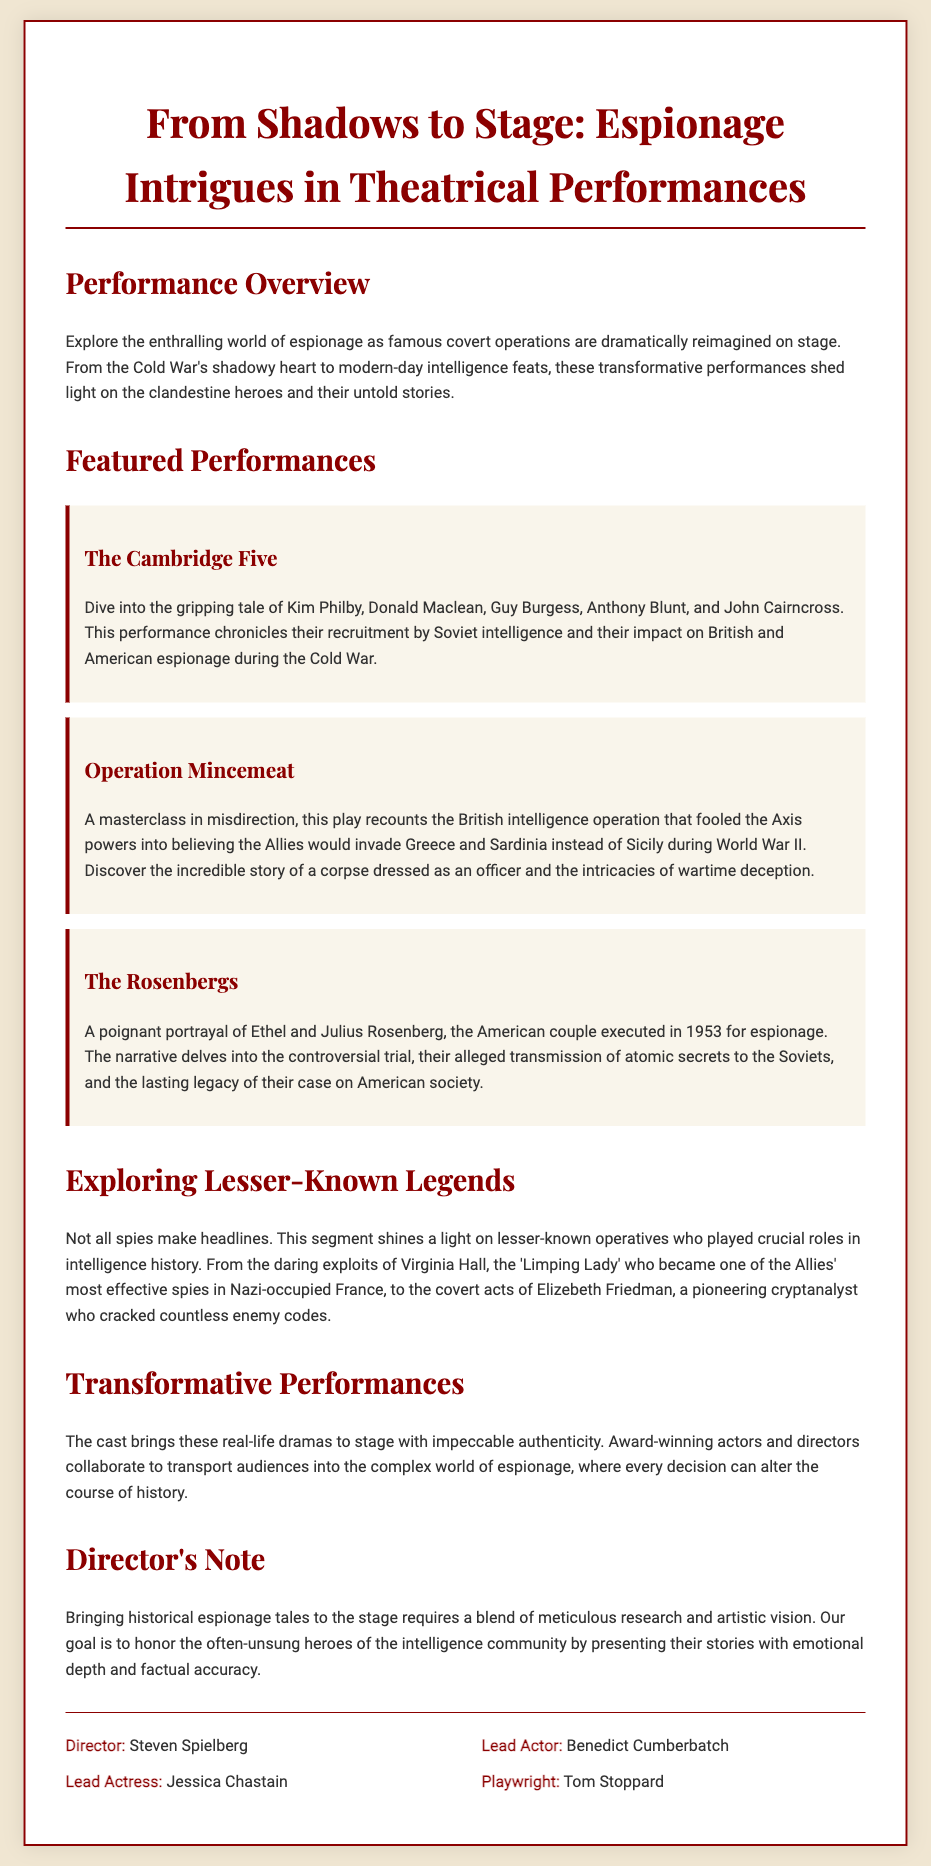what is the title of the play? The title of the play is prominently displayed at the top of the document.
Answer: From Shadows to Stage: Espionage Intrigues in Theatrical Performances who directed the play? The document lists the director in the credits section.
Answer: Steven Spielberg which performance features The Cambridge Five? The section on featured performances includes this title.
Answer: The Cambridge Five what is the theme of the play? The overview section describes the central theme of the play.
Answer: Espionage who is the playwright for this production? The playwright's name can be found in the credits section.
Answer: Tom Stoppard how many featured performances are listed? The number of featured performances can be counted from the document.
Answer: Three who plays the lead actress in the performance? The name of the lead actress is found in the credits section.
Answer: Jessica Chastain what is highlighted in the 'Exploring Lesser-Known Legends' section? This section discusses operatives that are not widely known.
Answer: Lesser-known operatives 